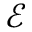Convert formula to latex. <formula><loc_0><loc_0><loc_500><loc_500>\mathcal { E }</formula> 